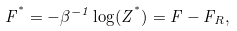Convert formula to latex. <formula><loc_0><loc_0><loc_500><loc_500>F ^ { ^ { * } } = - \beta ^ { - 1 } \log ( Z ^ { ^ { * } } ) = F - F _ { R } ,</formula> 